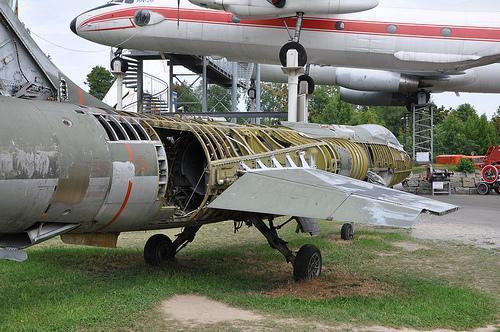How many planes are there?
Give a very brief answer. 2. How many airplanes are on the ground?
Give a very brief answer. 1. 